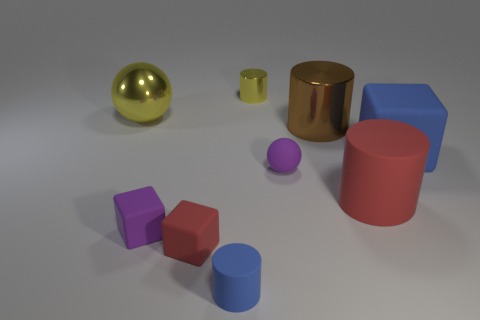Subtract all tiny yellow cylinders. How many cylinders are left? 3 Subtract all blue cylinders. How many cylinders are left? 3 Subtract 2 cylinders. How many cylinders are left? 2 Add 1 large blue metallic cylinders. How many objects exist? 10 Subtract all spheres. How many objects are left? 7 Subtract all green cubes. Subtract all small spheres. How many objects are left? 8 Add 2 yellow metallic things. How many yellow metallic things are left? 4 Add 8 tiny red objects. How many tiny red objects exist? 9 Subtract 1 blue cylinders. How many objects are left? 8 Subtract all gray balls. Subtract all brown cubes. How many balls are left? 2 